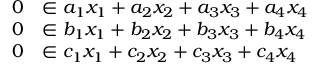Convert formula to latex. <formula><loc_0><loc_0><loc_500><loc_500>\begin{array} { r l } { 0 } & { \in a _ { 1 } x _ { 1 } + a _ { 2 } x _ { 2 } + a _ { 3 } x _ { 3 } + a _ { 4 } x _ { 4 } } \\ { 0 } & { \in b _ { 1 } x _ { 1 } + b _ { 2 } x _ { 2 } + b _ { 3 } x _ { 3 } + b _ { 4 } x _ { 4 } } \\ { 0 } & { \in c _ { 1 } x _ { 1 } + c _ { 2 } x _ { 2 } + c _ { 3 } x _ { 3 } + c _ { 4 } x _ { 4 } } \end{array}</formula> 